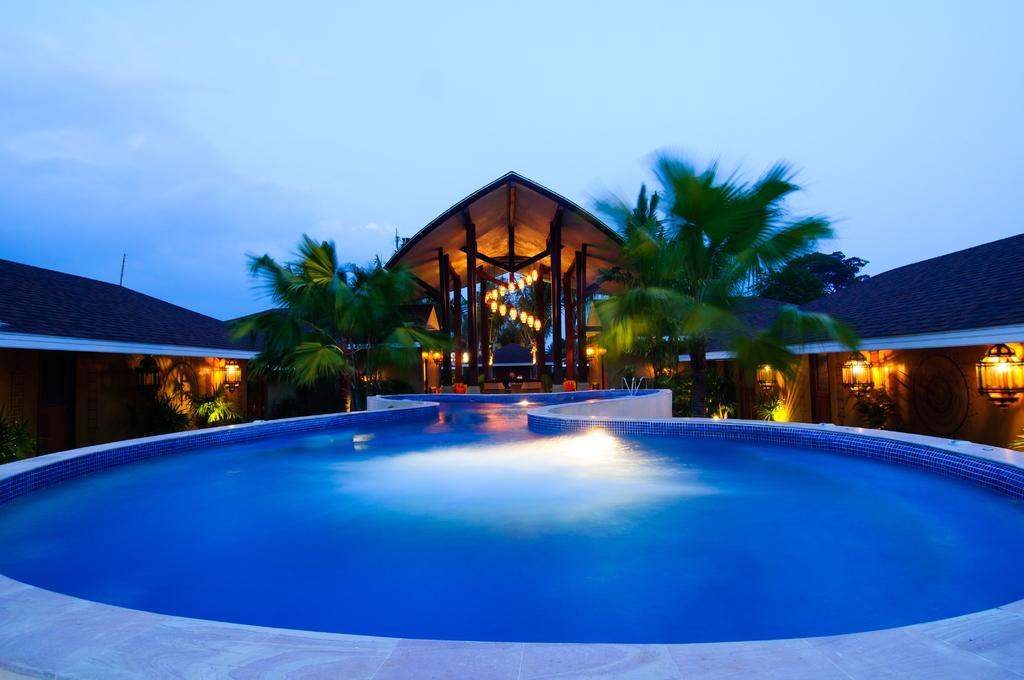What type of building is in the image? There is a house in the image. What can be seen illuminating the scene in the image? There are lights and lamps in the image. What type of natural elements are present in the image? There are trees in the image. What part of the natural environment is visible in the image? The sky is visible at the top of the image, and water is visible at the bottom of the image. How many visitors are present in the image? There is no indication of any visitors in the image. What type of store is visible in the image? There is no store present in the image. 